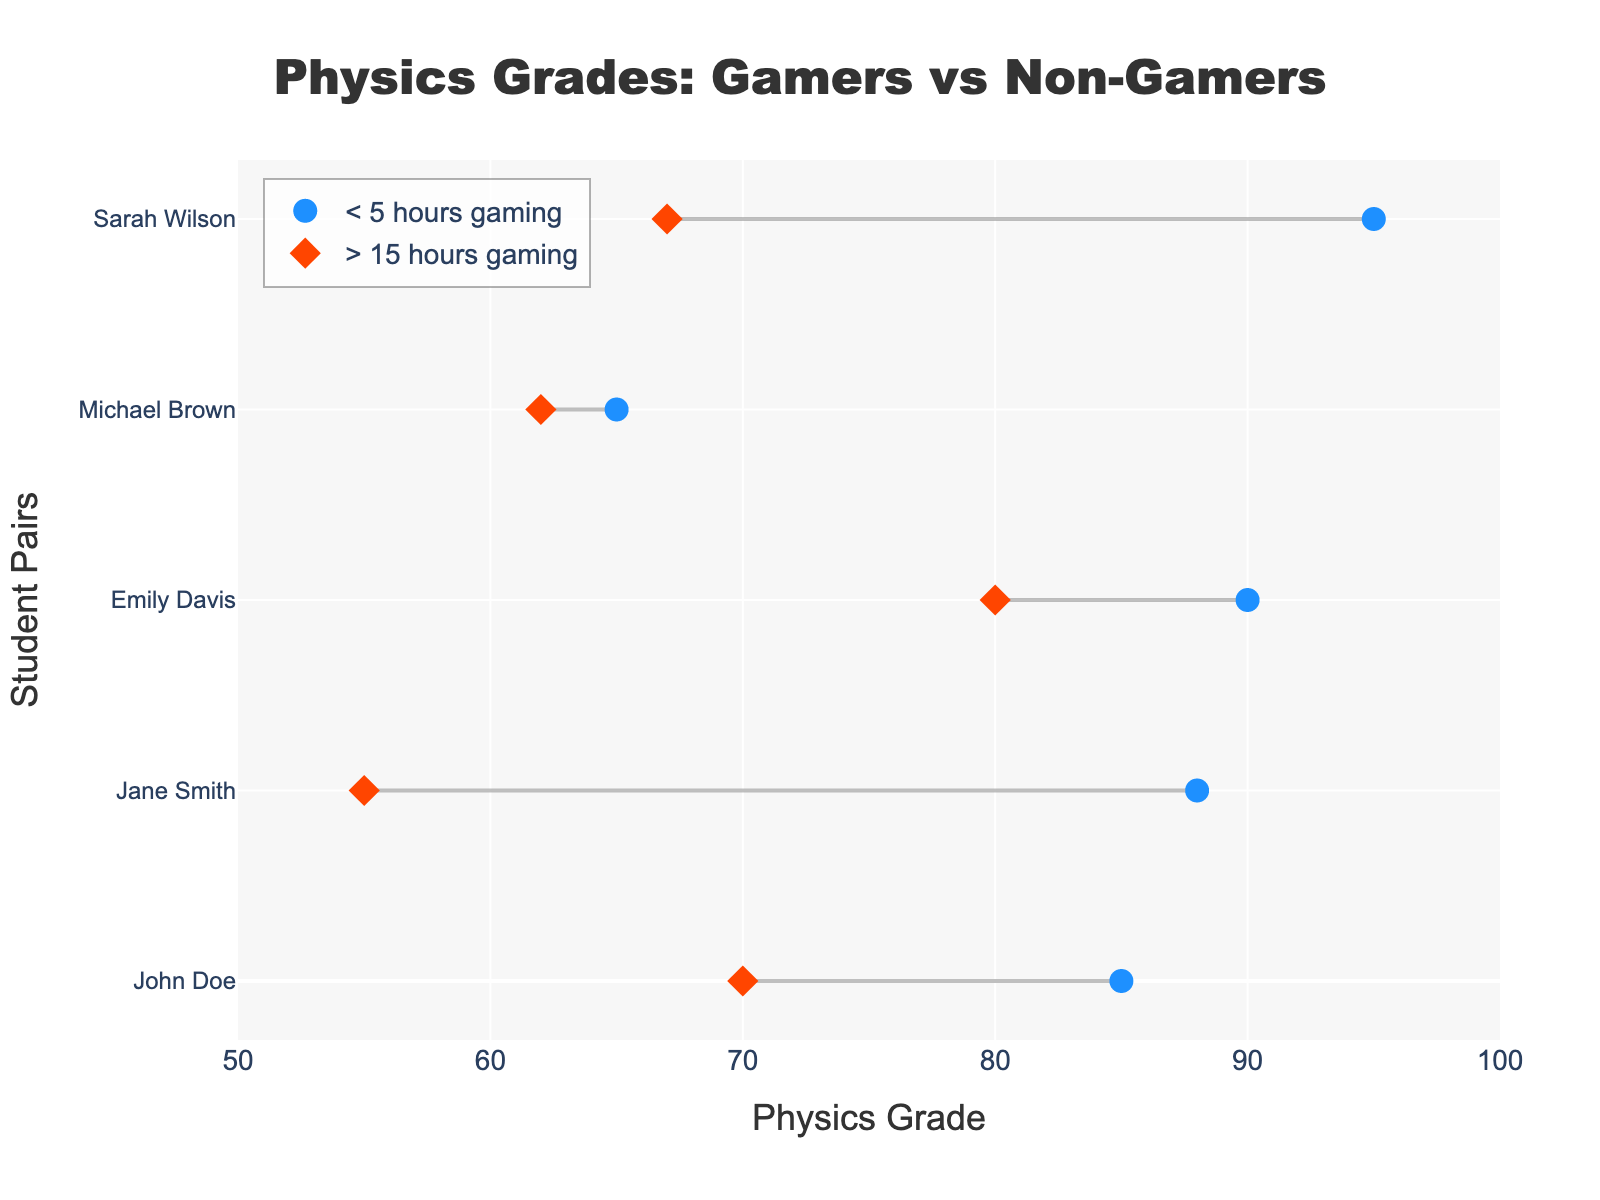What's the title of the plot? The title of a plot generally summarizes the main focus or the subject being depicted. In this plot, the title is positioned at the top and center of the figure, which usually captures the essence of the comparison being made. Here, it clearly states what is being compared: grades of students in relation to their gaming habits.
Answer: Physics Grades: Gamers vs Non-Gamers What is the x-axis label in the plot? The x-axis label provides the context of what the values along the horizontal axis represent. In this plot, it helps in understanding that the quantitative variations depict different levels of a specific measure, which are the "Physics Grade" scores of the students.
Answer: Physics Grade How many students game for less than 5 hours weekly? To find how many students game less than 5 hours weekly, you need to look at the plot markers specifically labeled as '< 5 hours gaming'. Each marker in this segment stands for one student, so counting these markers will give the number.
Answer: 6 How many students game for more than 15 hours weekly? Similar to finding the count for less than 5 hours, here we need to refer to the markers indicated as '> 15 hours gaming'. Count these markers to know the number of students who game more than 15 hours weekly.
Answer: 8 Which student has the highest Physics Grade in the < 5 hours gaming group? To identify this, look at the blue markers representing the students who game less than 5 hours. The one positioned farthest to the right along the x-axis corresponds to the highest grade.
Answer: Sarah Wilson How much higher is Sarah Wilson's grade compared to Robert Garcia's? Sarah Wilson's grade can be found among the blue markers, while Robert Garcia's among the red diamonds. Sarah Wilson's grade is 95, and Robert Garcia's grade is 55. Subtracting Robert's grade from Sarah's gives the difference. 95 - 55 = 40
Answer: 40 Which group has a wider range of Physics Grades? To determine this, look at the spread of grades for each group. The <5 hours group contains grades ranging from 65 to 95, while the >15 hours group ranges from 55 to 80. Subtract the minimum from the maximum in both groups to find the range and compare.
Answer: < 5 hours gaming Do students who game for more than 15 hours a week tend to have lower grades on average compared to those who game for less than 5 hours? Calculate the average grades for both groups by summing the grades for < 5 hours group (85+88+72+90+65+95) and dividing by 6, then sum the grades for > 15 hours group (60+70+55+80+62+67+75+77) and divide by 8. Then compare the two averages.
Answer: Yes What is the average grade difference between the two groups? First, calculate the average grades for both groups individually as shown previously. For < 5 hours group: (85+88+72+90+65+95)/6 = 82.5, and for > 15 hours group: (60+70+55+80+62+67+75+77)/8 ≈ 68.25. Subtract the average of the more than 15 hours group from the less than 5 hours group: 82.5 - 68.25 = 14.25.
Answer: 14.25 Is there any student pair where the student who games more than 15 hours has a higher grade than a student who games less than 5 hours? Compare each student pair connected by the gray lines. Look for any instance where a red diamond (gaming >15 hours) is positioned to the right (i.e., having a higher grade) of a corresponding blue circle (gaming <5 hours).
Answer: No 